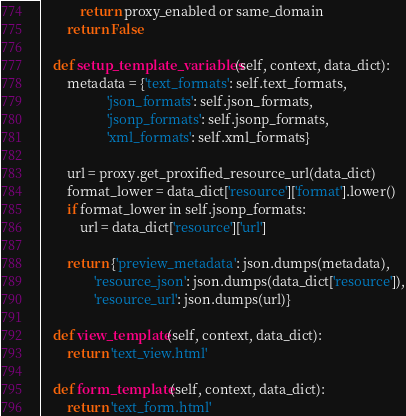<code> <loc_0><loc_0><loc_500><loc_500><_Python_>            return proxy_enabled or same_domain
        return False

    def setup_template_variables(self, context, data_dict):
        metadata = {'text_formats': self.text_formats,
                    'json_formats': self.json_formats,
                    'jsonp_formats': self.jsonp_formats,
                    'xml_formats': self.xml_formats}

        url = proxy.get_proxified_resource_url(data_dict)
        format_lower = data_dict['resource']['format'].lower()
        if format_lower in self.jsonp_formats:
            url = data_dict['resource']['url']

        return {'preview_metadata': json.dumps(metadata),
                'resource_json': json.dumps(data_dict['resource']),
                'resource_url': json.dumps(url)}

    def view_template(self, context, data_dict):
        return 'text_view.html'

    def form_template(self, context, data_dict):
        return 'text_form.html'
</code> 